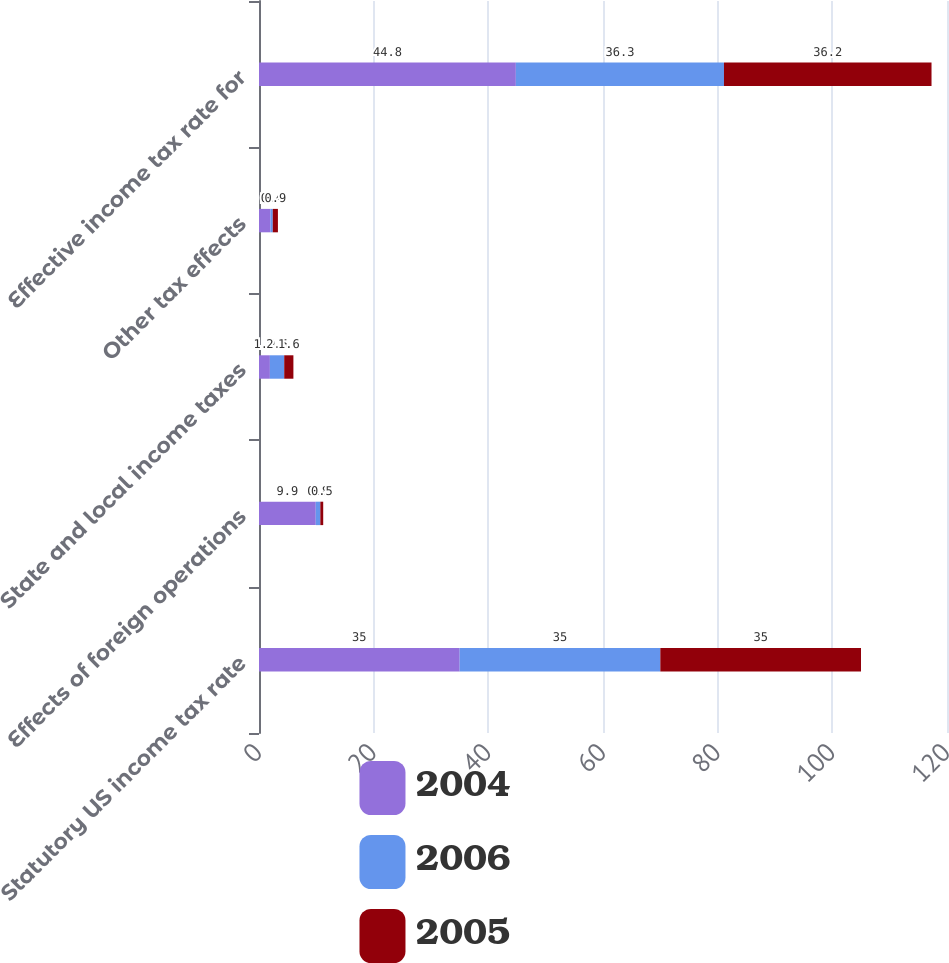Convert chart. <chart><loc_0><loc_0><loc_500><loc_500><stacked_bar_chart><ecel><fcel>Statutory US income tax rate<fcel>Effects of foreign operations<fcel>State and local income taxes<fcel>Other tax effects<fcel>Effective income tax rate for<nl><fcel>2004<fcel>35<fcel>9.9<fcel>1.9<fcel>2<fcel>44.8<nl><fcel>2006<fcel>35<fcel>0.8<fcel>2.5<fcel>0.4<fcel>36.3<nl><fcel>2005<fcel>35<fcel>0.5<fcel>1.6<fcel>0.9<fcel>36.2<nl></chart> 